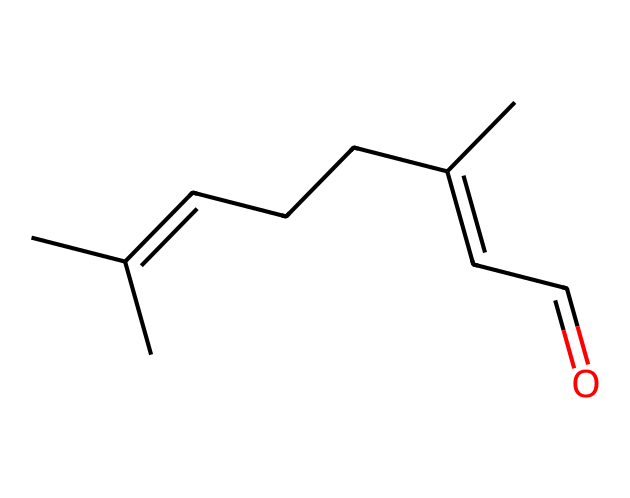What is the total number of carbon atoms in this molecule? By examining the SMILES representation, we can count the carbon atoms represented by each "C". There are a total of 10 carbon atoms in the chain.
Answer: 10 How many double bonds are present in citral? In the provided SMILES, there are two occurrences of double bonds indicated by the "=" sign, representing two double bonds in the structure.
Answer: 2 What is the functional group present in this compound? The ending part "C=O" in the SMILES indicates the presence of a carbonyl group (aldehyde), which is characteristic of aldehydes such as citral.
Answer: aldehyde What type of isomerism does this molecule exhibit? This molecule exhibits geometric isomerism, specifically E-Z isomerism, due to the presence of restricted rotation around the double bonds in the structure.
Answer: E-Z isomerism Which configuration is often more stable in geometric isomers, E or Z for citral? Generally, the E configuration is more stable in citral because of the position of higher priority substituents being on opposite sides of the double bond.
Answer: E What is the effect of the Z configuration of citral on its properties? The Z configuration can increase polarity as substituents are on the same side, which may lead to differences in boiling point and solubility compared to the E configuration.
Answer: polarity What role does citral play in herbal teas? Citral is mainly known for its calming and soothing properties, making it a popular compound in herbal teas designed to promote relaxation.
Answer: calming agent 